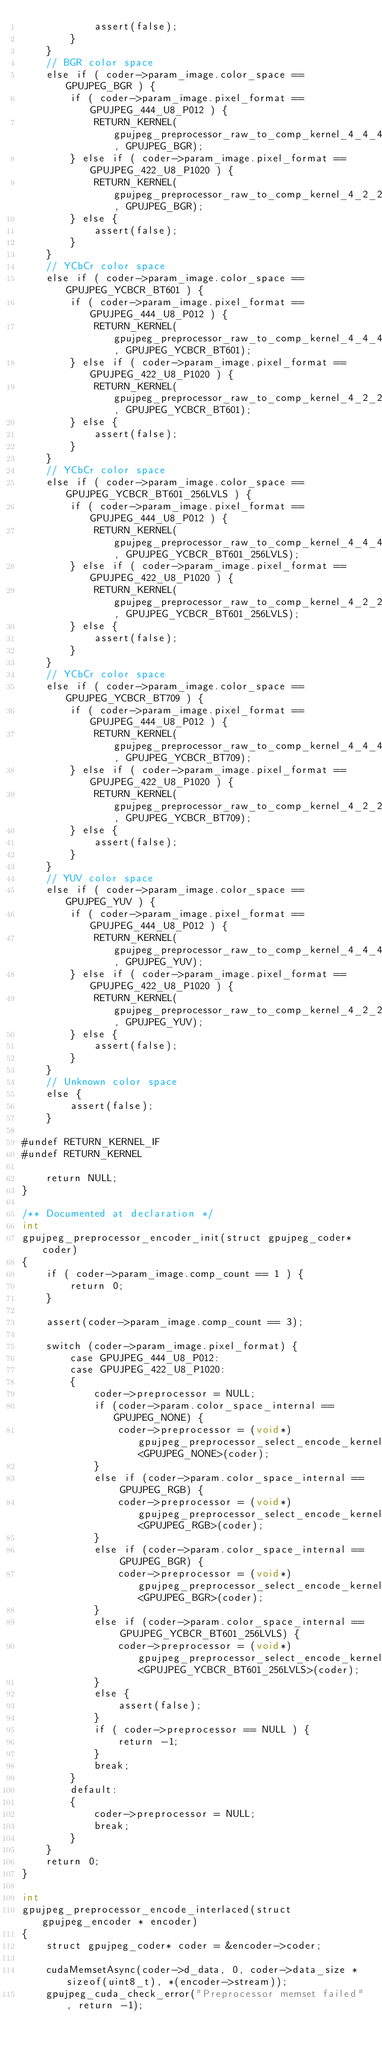Convert code to text. <code><loc_0><loc_0><loc_500><loc_500><_Cuda_>            assert(false);
        }
    }
    // BGR color space
    else if ( coder->param_image.color_space == GPUJPEG_BGR ) {
        if ( coder->param_image.pixel_format == GPUJPEG_444_U8_P012 ) {
            RETURN_KERNEL(gpujpeg_preprocessor_raw_to_comp_kernel_4_4_4, GPUJPEG_BGR);
        } else if ( coder->param_image.pixel_format == GPUJPEG_422_U8_P1020 ) {
            RETURN_KERNEL(gpujpeg_preprocessor_raw_to_comp_kernel_4_2_2, GPUJPEG_BGR);
        } else {
            assert(false);
        }
    }
    // YCbCr color space
    else if ( coder->param_image.color_space == GPUJPEG_YCBCR_BT601 ) {
        if ( coder->param_image.pixel_format == GPUJPEG_444_U8_P012 ) {
            RETURN_KERNEL(gpujpeg_preprocessor_raw_to_comp_kernel_4_4_4, GPUJPEG_YCBCR_BT601);
        } else if ( coder->param_image.pixel_format == GPUJPEG_422_U8_P1020 ) {
            RETURN_KERNEL(gpujpeg_preprocessor_raw_to_comp_kernel_4_2_2, GPUJPEG_YCBCR_BT601);
        } else {
            assert(false);
        }
    }
    // YCbCr color space
    else if ( coder->param_image.color_space == GPUJPEG_YCBCR_BT601_256LVLS ) {
        if ( coder->param_image.pixel_format == GPUJPEG_444_U8_P012 ) {
            RETURN_KERNEL(gpujpeg_preprocessor_raw_to_comp_kernel_4_4_4, GPUJPEG_YCBCR_BT601_256LVLS);
        } else if ( coder->param_image.pixel_format == GPUJPEG_422_U8_P1020 ) {
            RETURN_KERNEL(gpujpeg_preprocessor_raw_to_comp_kernel_4_2_2, GPUJPEG_YCBCR_BT601_256LVLS);
        } else {
            assert(false);
        }
    }
    // YCbCr color space
    else if ( coder->param_image.color_space == GPUJPEG_YCBCR_BT709 ) {
        if ( coder->param_image.pixel_format == GPUJPEG_444_U8_P012 ) {
            RETURN_KERNEL(gpujpeg_preprocessor_raw_to_comp_kernel_4_4_4, GPUJPEG_YCBCR_BT709);
        } else if ( coder->param_image.pixel_format == GPUJPEG_422_U8_P1020 ) {
            RETURN_KERNEL(gpujpeg_preprocessor_raw_to_comp_kernel_4_2_2, GPUJPEG_YCBCR_BT709);
        } else {
            assert(false);
        }
    }
    // YUV color space
    else if ( coder->param_image.color_space == GPUJPEG_YUV ) {
        if ( coder->param_image.pixel_format == GPUJPEG_444_U8_P012 ) {
            RETURN_KERNEL(gpujpeg_preprocessor_raw_to_comp_kernel_4_4_4, GPUJPEG_YUV);
        } else if ( coder->param_image.pixel_format == GPUJPEG_422_U8_P1020 ) {
            RETURN_KERNEL(gpujpeg_preprocessor_raw_to_comp_kernel_4_2_2, GPUJPEG_YUV);
        } else {
            assert(false);
        }
    }
    // Unknown color space
    else {
        assert(false);
    }

#undef RETURN_KERNEL_IF
#undef RETURN_KERNEL

    return NULL;
}

/** Documented at declaration */
int
gpujpeg_preprocessor_encoder_init(struct gpujpeg_coder* coder)
{
    if ( coder->param_image.comp_count == 1 ) {
        return 0;
    }

    assert(coder->param_image.comp_count == 3);

    switch (coder->param_image.pixel_format) {
        case GPUJPEG_444_U8_P012:
        case GPUJPEG_422_U8_P1020:
        {
            coder->preprocessor = NULL;
            if (coder->param.color_space_internal == GPUJPEG_NONE) {
                coder->preprocessor = (void*)gpujpeg_preprocessor_select_encode_kernel<GPUJPEG_NONE>(coder);
            }
            else if (coder->param.color_space_internal == GPUJPEG_RGB) {
                coder->preprocessor = (void*)gpujpeg_preprocessor_select_encode_kernel<GPUJPEG_RGB>(coder);
            }
            else if (coder->param.color_space_internal == GPUJPEG_BGR) {
                coder->preprocessor = (void*)gpujpeg_preprocessor_select_encode_kernel<GPUJPEG_BGR>(coder);
            }
            else if (coder->param.color_space_internal == GPUJPEG_YCBCR_BT601_256LVLS) {
                coder->preprocessor = (void*)gpujpeg_preprocessor_select_encode_kernel<GPUJPEG_YCBCR_BT601_256LVLS>(coder);
            }
            else {
                assert(false);
            }
            if ( coder->preprocessor == NULL ) {
                return -1;
            }
            break;
        }
        default:
        {
            coder->preprocessor = NULL;
            break;
        }
    }
    return 0;
}

int
gpujpeg_preprocessor_encode_interlaced(struct gpujpeg_encoder * encoder)
{
    struct gpujpeg_coder* coder = &encoder->coder;

    cudaMemsetAsync(coder->d_data, 0, coder->data_size * sizeof(uint8_t), *(encoder->stream));
    gpujpeg_cuda_check_error("Preprocessor memset failed", return -1);
</code> 